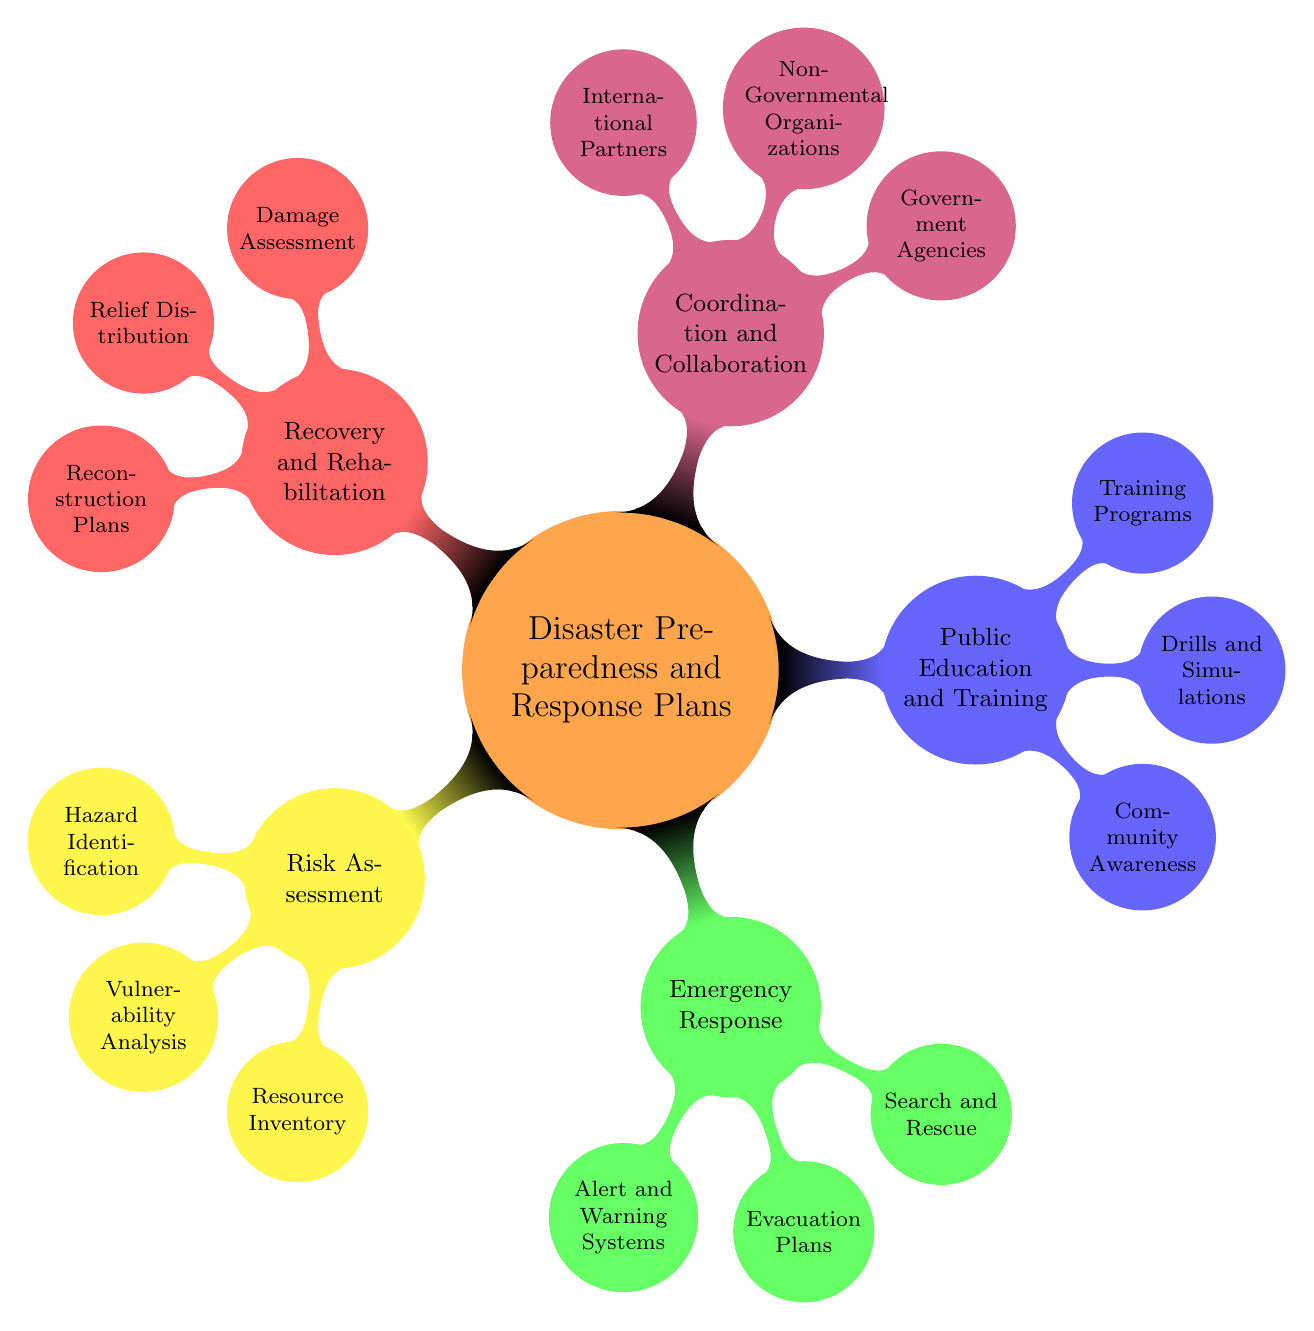What are the main components of Disaster Preparedness and Response Plans? The diagram shows five main components: Risk Assessment, Emergency Response, Public Education and Training, Coordination and Collaboration, and Recovery and Rehabilitation.
Answer: Risk Assessment, Emergency Response, Public Education and Training, Coordination and Collaboration, Recovery and Rehabilitation How many nodes are under the Emergency Response section? In the Emergency Response section, there are three nodes: Alert and Warning Systems, Evacuation Plans, and Search and Rescue.
Answer: 3 What is included in the Risk Assessment nodes? The Risk Assessment nodes include Hazard Identification, Vulnerability Analysis, and Resource Inventory. Therefore, the content of this section consists of these three elements.
Answer: Hazard Identification, Vulnerability Analysis, Resource Inventory Which organization is listed under Coordination and Collaboration? The Coordination and Collaboration section includes Government Agencies, Non-Governmental Organizations, and International Partners. One specific government agency mentioned is NEMA.
Answer: NEMA Name one aspect of Public Education and Training. The Public Education and Training section consists of three aspects: Community Awareness, Drills and Simulations, and Training Programs. One aspect is Community Awareness.
Answer: Community Awareness What is the purpose of the Recovery and Rehabilitation section? The Recovery and Rehabilitation section focuses on restoring the community after a disaster. It includes Damage Assessment, Relief Distribution, and Reconstruction Plans, aiming to recover from and rebuild after disasters.
Answer: Restoring the community after a disaster How does the number of nodes in Risk Assessment compare to those in Public Education and Training? The Risk Assessment section has three nodes, while the Public Education and Training section also contains three nodes. They have an equal number of nodes, totaling three in each category.
Answer: Equal What types of disasters are identified in the Hazard Identification? The diagram outlines types of disasters such as Floods, Fires, and Pandemics under Hazard Identification. These are specific examples included in the Risk Assessment node.
Answer: Floods, Fires, Pandemics Which node indicates the methods of Alert and Warning Systems? The Alert and Warning Systems node specifies how alerts and warnings will be communicated, including methods like SMS Alerts, Radio Announcements, and Social Media. These specific methods illustrate the channels for disseminating information.
Answer: SMS Alerts, Radio Announcements, Social Media 